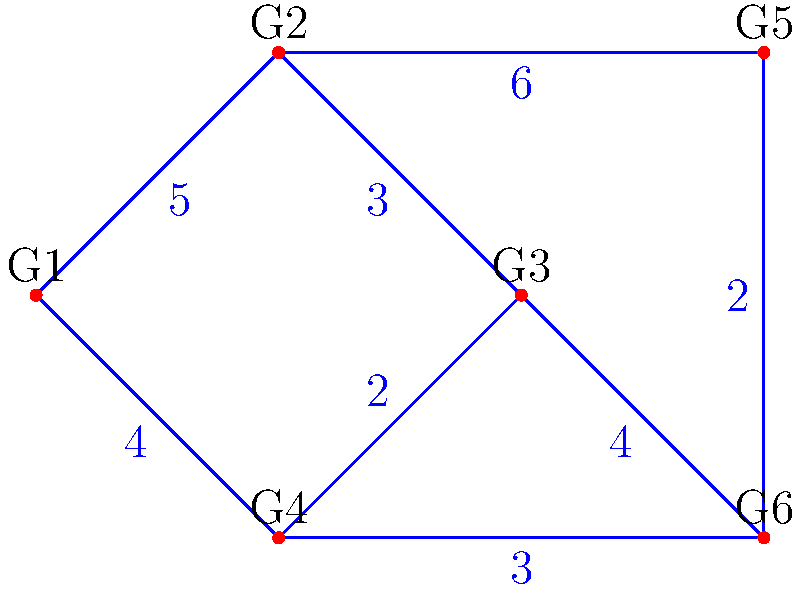As a drummer exploring rhythmic patterns across different genres, you've created a graph where each vertex represents a specific genre (G1 to G6), and the edges represent the rhythmic similarity between genres, with weights indicating the difficulty of transitioning between them. What is the total weight of the minimum spanning tree that connects all genres with the smoothest overall transitions? To find the minimum spanning tree (MST) in this graph, we'll use Kruskal's algorithm:

1. Sort all edges by weight in ascending order:
   (G4, G6): 2
   (G3, G4): 2
   (G2, G3): 3
   (G4, G5): 3
   (G1, G4): 4
   (G3, G6): 4
   (G1, G2): 5
   (G2, G5): 6

2. Start with an empty MST and add edges in order, skipping those that would create a cycle:
   - Add (G4, G6): 2
   - Add (G3, G4): 2
   - Add (G2, G3): 3
   - Add (G4, G5): 3
   - Add (G1, G4): 4

3. We now have 5 edges connecting all 6 vertices, forming the MST.

4. Calculate the total weight of the MST:
   2 + 2 + 3 + 3 + 4 = 14

Therefore, the total weight of the minimum spanning tree is 14.
Answer: 14 